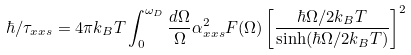<formula> <loc_0><loc_0><loc_500><loc_500>\hbar { / } \tau _ { x x s } = 4 \pi k _ { B } T \int _ { 0 } ^ { \omega _ { D } } \frac { d \Omega } { \Omega } \alpha ^ { 2 } _ { x x s } F ( \Omega ) \left [ \frac { \hbar { \Omega } / 2 k _ { B } T } { \sinh ( \hbar { \Omega } / 2 k _ { B } T ) } \right ] ^ { 2 }</formula> 